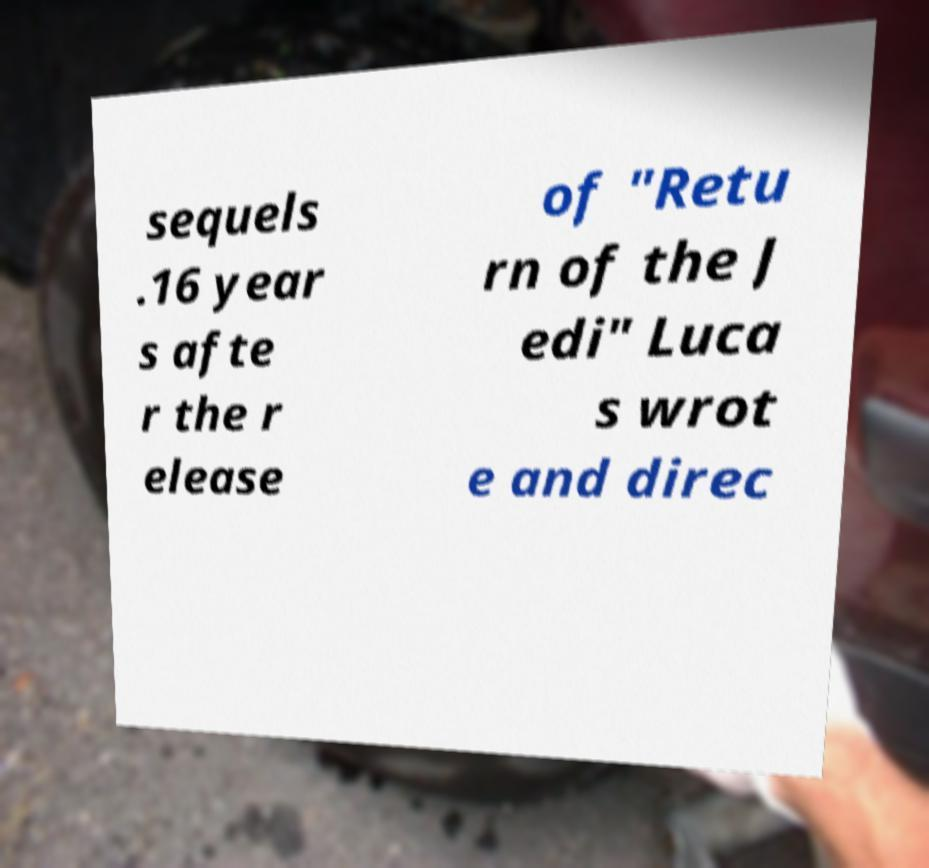Please read and relay the text visible in this image. What does it say? sequels .16 year s afte r the r elease of "Retu rn of the J edi" Luca s wrot e and direc 